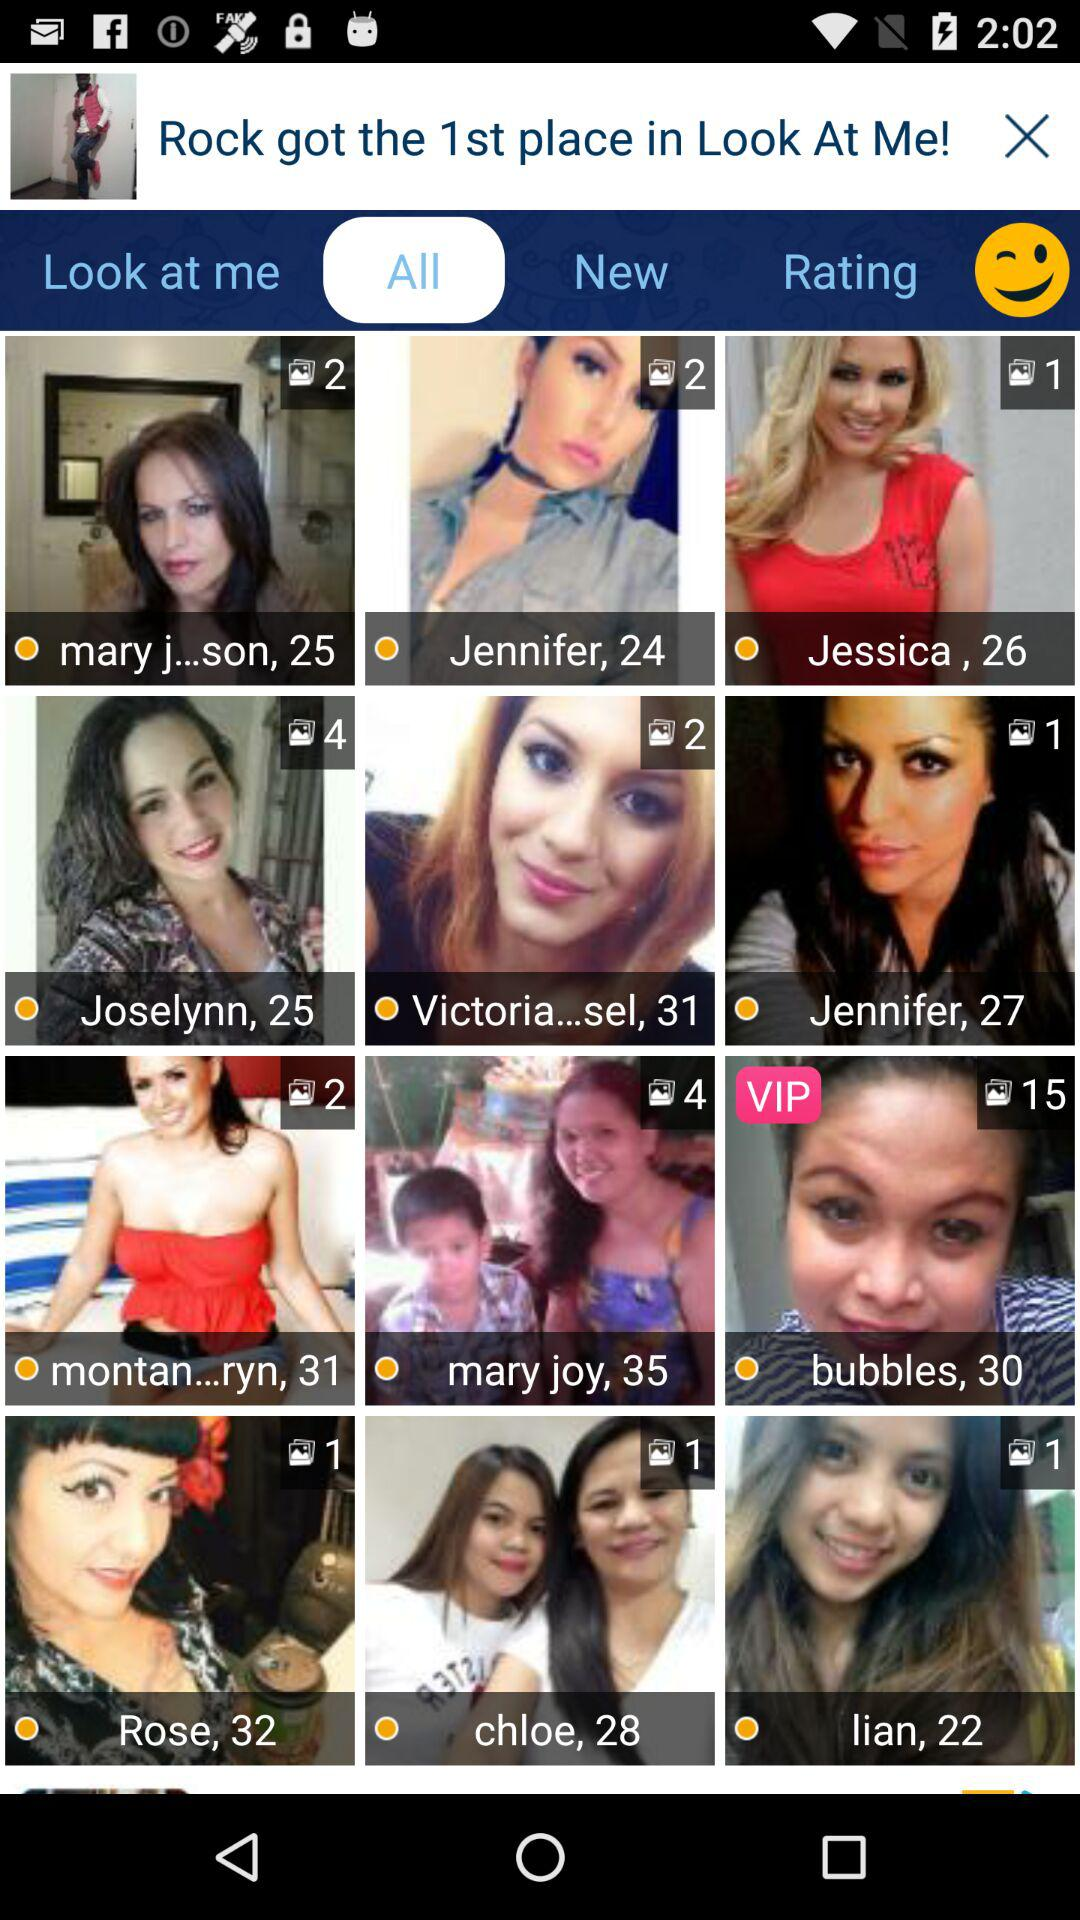Which tab is selected? The selected tab is "All". 